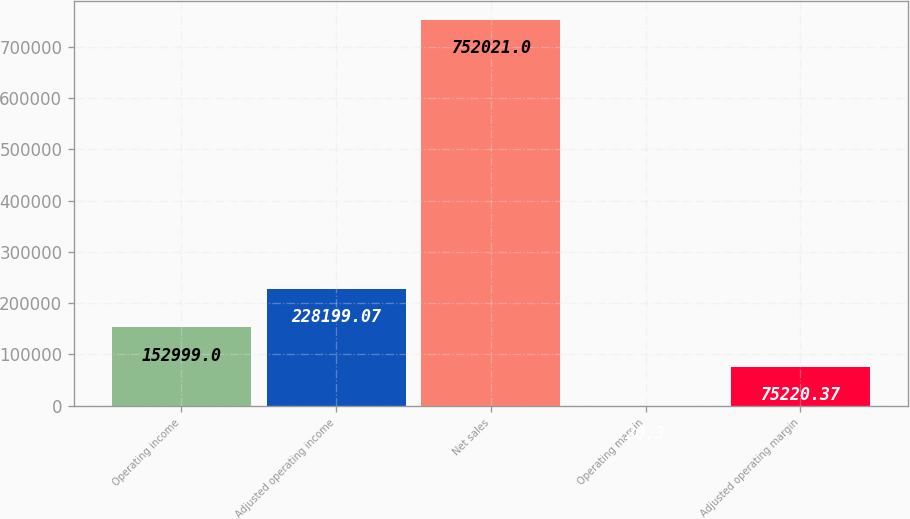Convert chart to OTSL. <chart><loc_0><loc_0><loc_500><loc_500><bar_chart><fcel>Operating income<fcel>Adjusted operating income<fcel>Net sales<fcel>Operating margin<fcel>Adjusted operating margin<nl><fcel>152999<fcel>228199<fcel>752021<fcel>20.3<fcel>75220.4<nl></chart> 